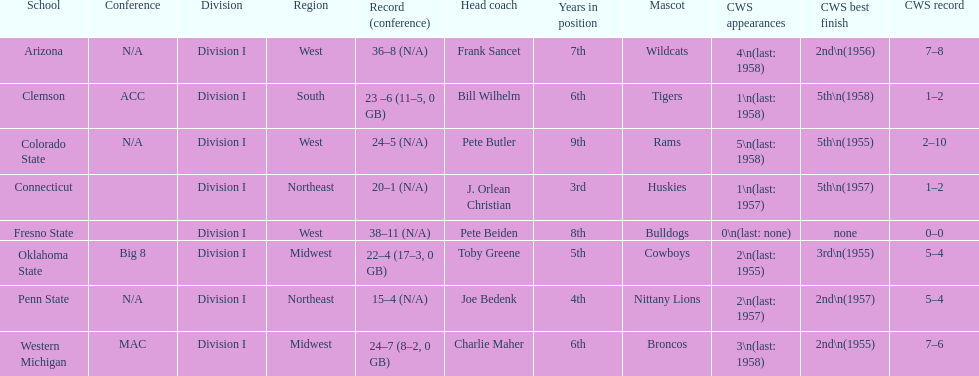Identify the schools that have been runners-up in the cws best finish standings. Arizona, Penn State, Western Michigan. Write the full table. {'header': ['School', 'Conference', 'Division', 'Region', 'Record (conference)', 'Head coach', 'Years in position', 'Mascot', 'CWS appearances', 'CWS best finish', 'CWS record'], 'rows': [['Arizona', 'N/A', 'Division I', 'West', '36–8 (N/A)', 'Frank Sancet', '7th', 'Wildcats', '4\\n(last: 1958)', '2nd\\n(1956)', '7–8'], ['Clemson', 'ACC', 'Division I', 'South', '23 –6 (11–5, 0 GB)', 'Bill Wilhelm', '6th', 'Tigers', '1\\n(last: 1958)', '5th\\n(1958)', '1–2'], ['Colorado State', 'N/A', 'Division I', 'West', '24–5 (N/A)', 'Pete Butler', '9th', 'Rams', '5\\n(last: 1958)', '5th\\n(1955)', '2–10'], ['Connecticut', '', 'Division I', 'Northeast', '20–1 (N/A)', 'J. Orlean Christian', '3rd', 'Huskies', '1\\n(last: 1957)', '5th\\n(1957)', '1–2'], ['Fresno State', '', 'Division I', 'West', '38–11 (N/A)', 'Pete Beiden', '8th', 'Bulldogs', '0\\n(last: none)', 'none', '0–0'], ['Oklahoma State', 'Big 8', 'Division I', 'Midwest', '22–4 (17–3, 0 GB)', 'Toby Greene', '5th', 'Cowboys', '2\\n(last: 1955)', '3rd\\n(1955)', '5–4'], ['Penn State', 'N/A', 'Division I', 'Northeast', '15–4 (N/A)', 'Joe Bedenk', '4th', 'Nittany Lions', '2\\n(last: 1957)', '2nd\\n(1957)', '5–4'], ['Western Michigan', 'MAC', 'Division I', 'Midwest', '24–7 (8–2, 0 GB)', 'Charlie Maher', '6th', 'Broncos', '3\\n(last: 1958)', '2nd\\n(1955)', '7–6']]} 